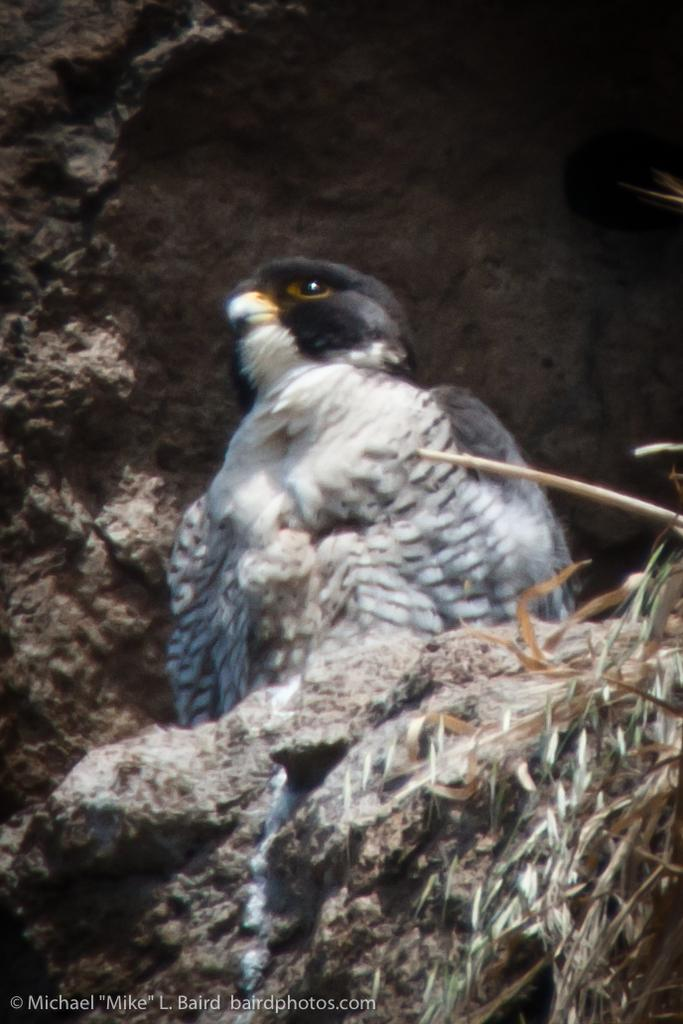What type of animal is in the image? There is a bird in the image. Can you describe the bird's coloring? The bird has white and black coloring. What is the color of the background in the image? The background in the image is black. What else can be seen in the image besides the bird? Dry leaves are present in the image. What type of surprise does the bird have for the beast in the image? There is no beast present in the image, and therefore no interaction between the bird and a beast can be observed. 